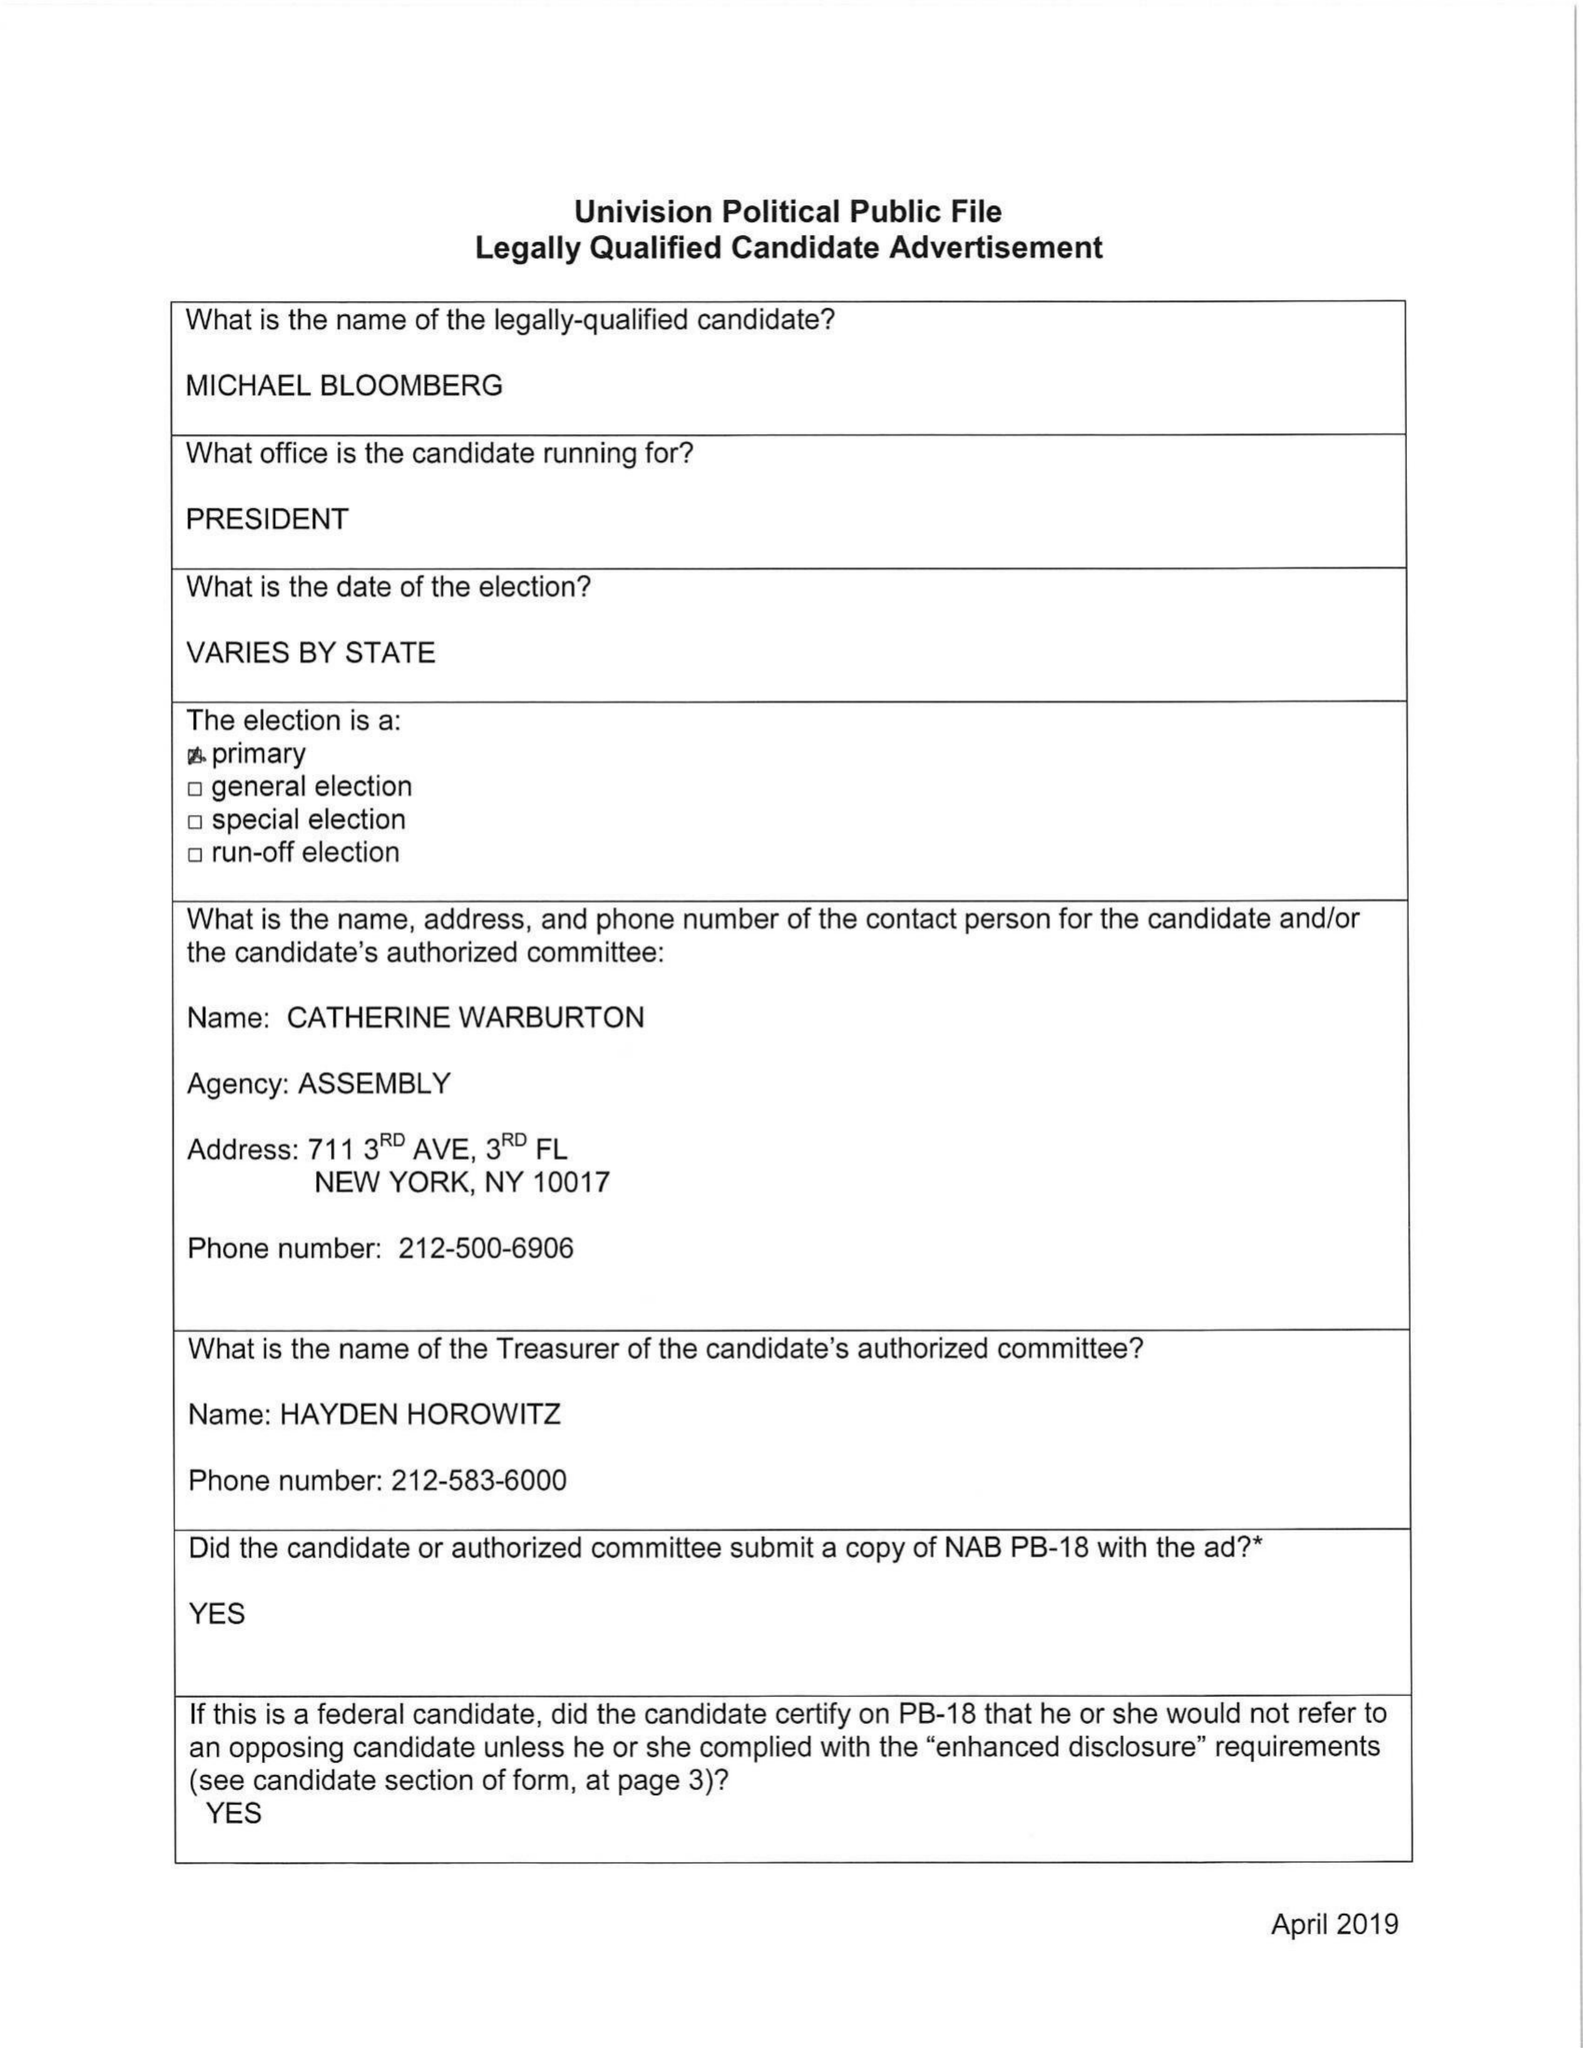What is the value for the gross_amount?
Answer the question using a single word or phrase. None 